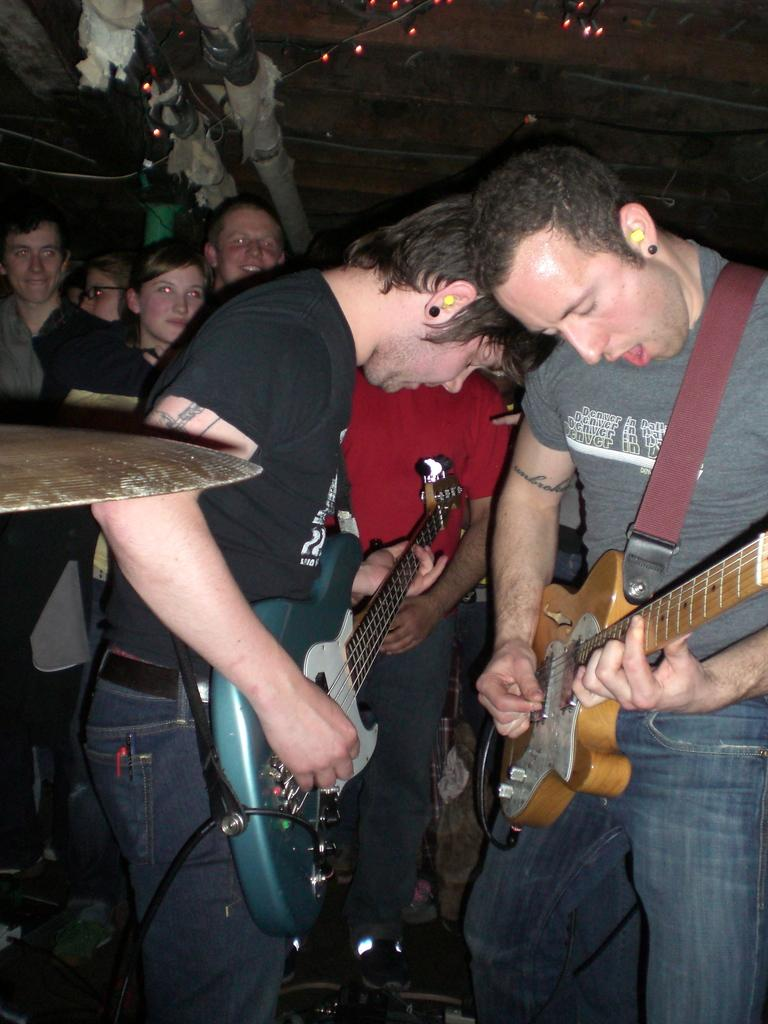How many people are in the image? There are people in the image, but the exact number is not specified. What are some of the people doing in the image? Some of the people are standing, and some of the standing people are holding guitars. Are there any other people visible in the image? Yes, there are other people standing in the background. Can you see a chair in the lake in the image? There is no chair or lake present in the image. How many times do the people jump in the image? The people in the image are not jumping; they are standing and holding guitars. 